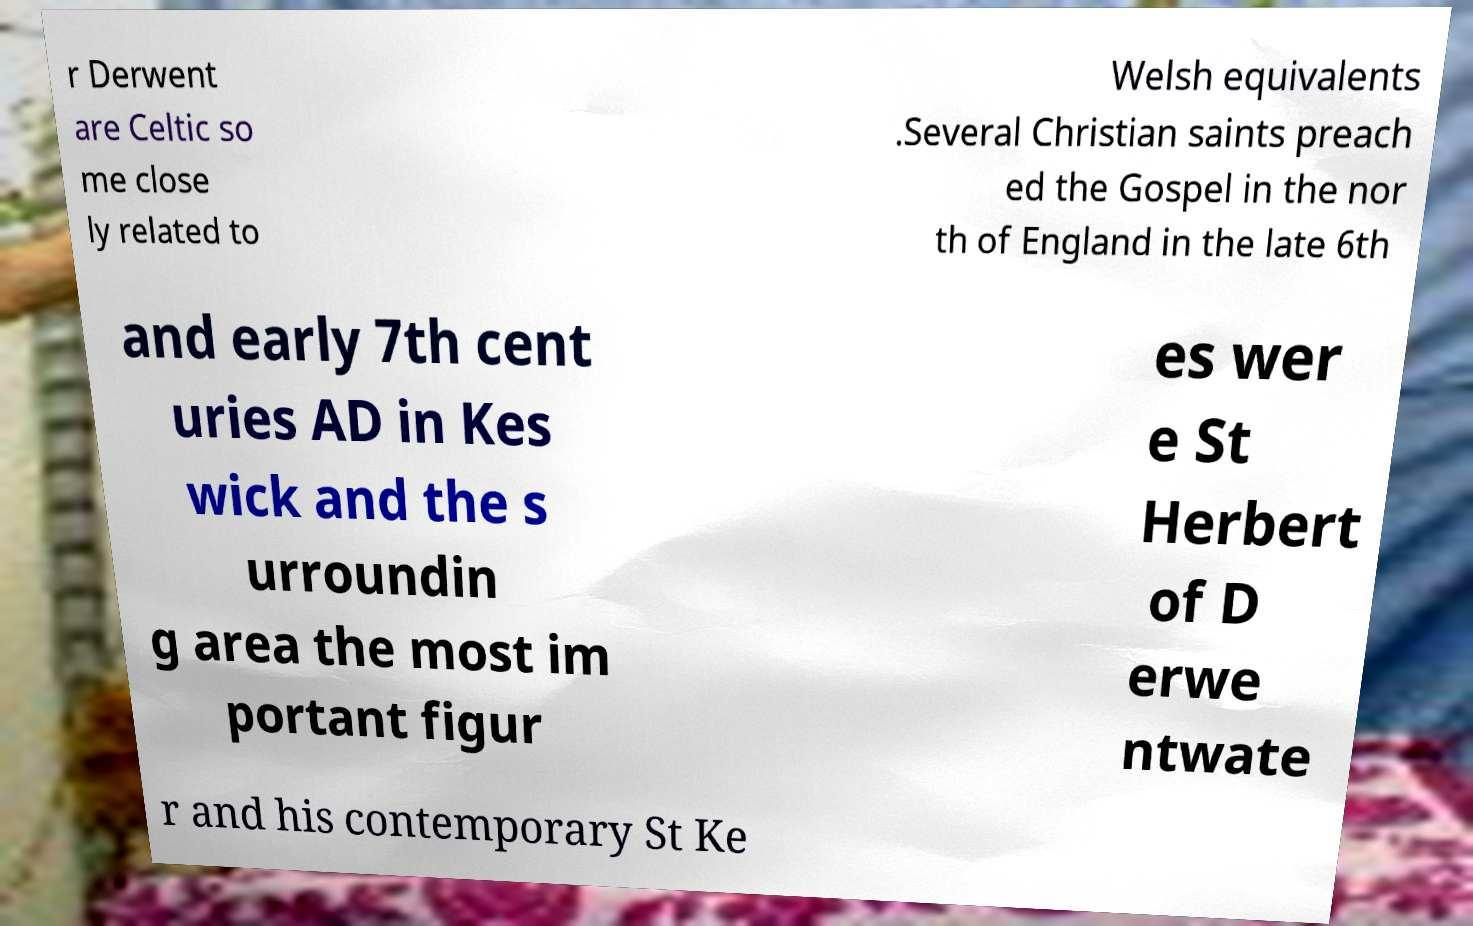Can you read and provide the text displayed in the image?This photo seems to have some interesting text. Can you extract and type it out for me? r Derwent are Celtic so me close ly related to Welsh equivalents .Several Christian saints preach ed the Gospel in the nor th of England in the late 6th and early 7th cent uries AD in Kes wick and the s urroundin g area the most im portant figur es wer e St Herbert of D erwe ntwate r and his contemporary St Ke 